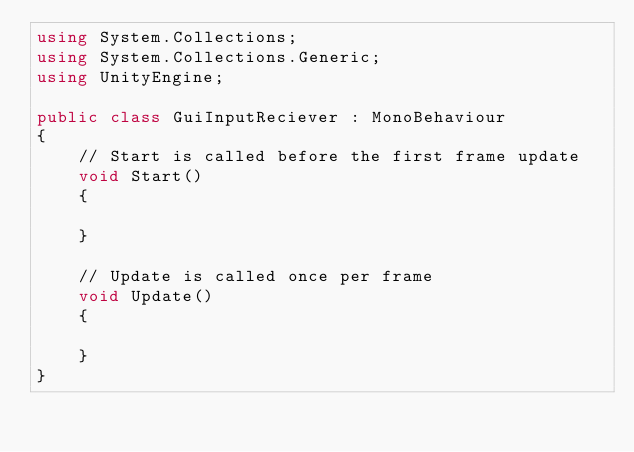Convert code to text. <code><loc_0><loc_0><loc_500><loc_500><_C#_>using System.Collections;
using System.Collections.Generic;
using UnityEngine;

public class GuiInputReciever : MonoBehaviour
{
    // Start is called before the first frame update
    void Start()
    {
        
    }

    // Update is called once per frame
    void Update()
    {
        
    }
}
</code> 